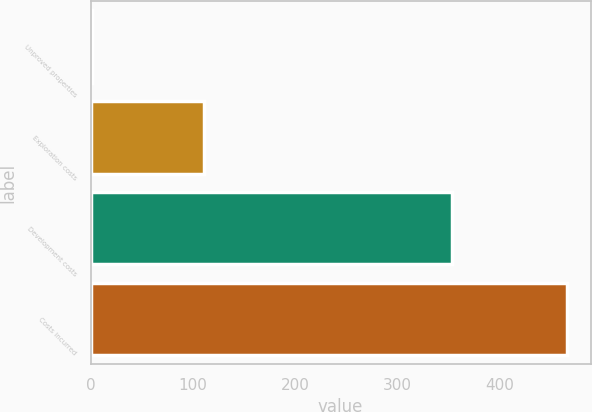Convert chart to OTSL. <chart><loc_0><loc_0><loc_500><loc_500><bar_chart><fcel>Unproved properties<fcel>Exploration costs<fcel>Development costs<fcel>Costs incurred<nl><fcel>1<fcel>111<fcel>354<fcel>466<nl></chart> 